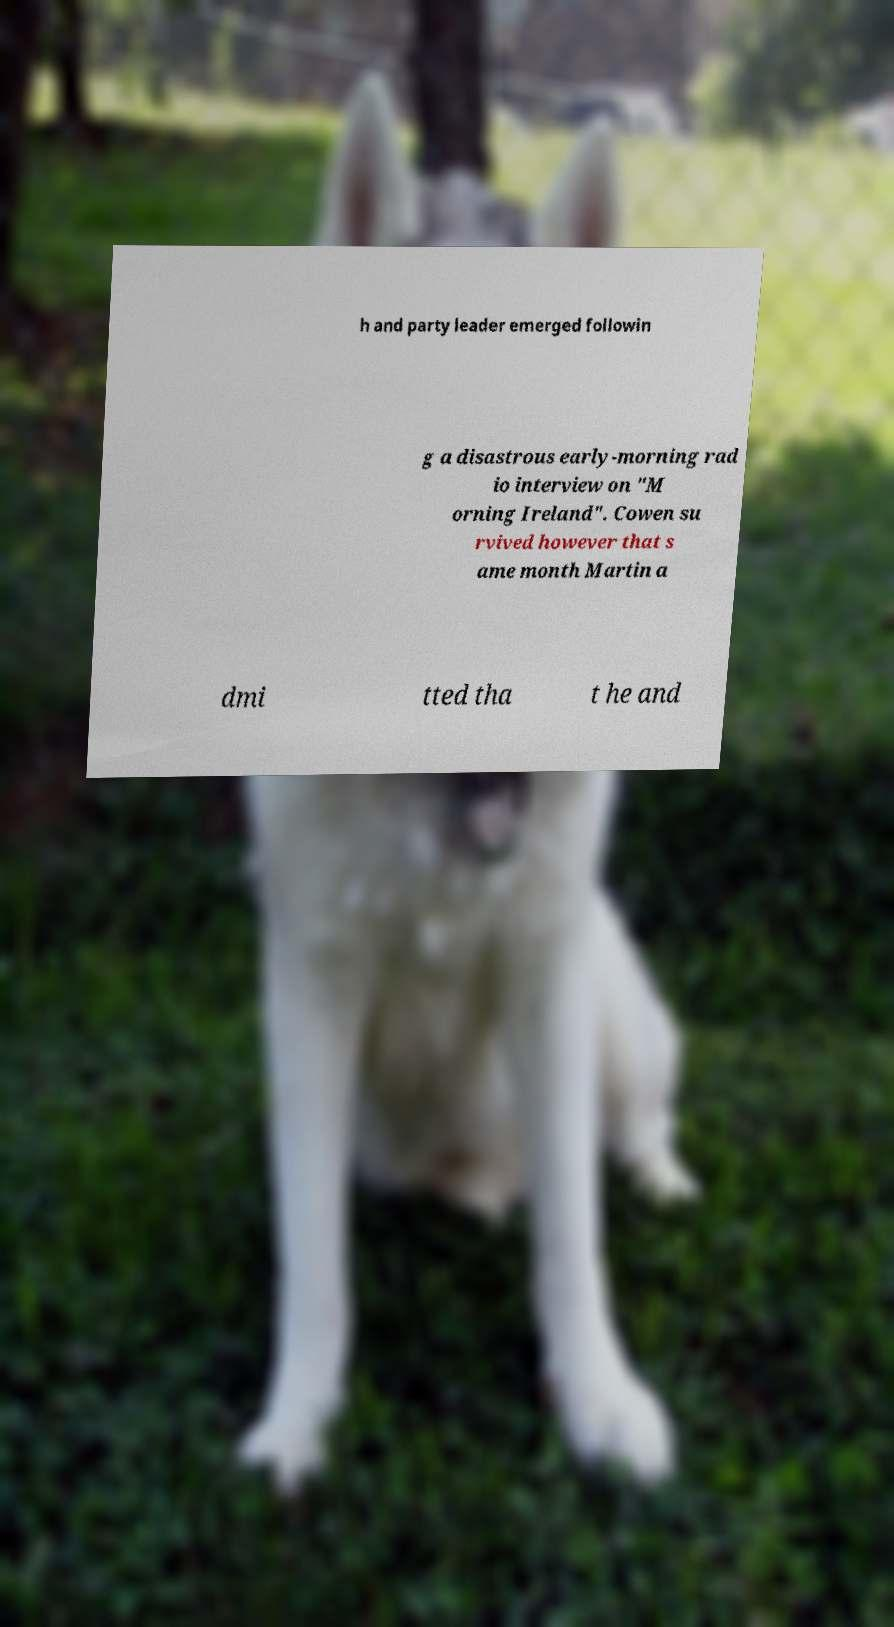Could you extract and type out the text from this image? h and party leader emerged followin g a disastrous early-morning rad io interview on "M orning Ireland". Cowen su rvived however that s ame month Martin a dmi tted tha t he and 